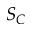Convert formula to latex. <formula><loc_0><loc_0><loc_500><loc_500>S _ { C }</formula> 